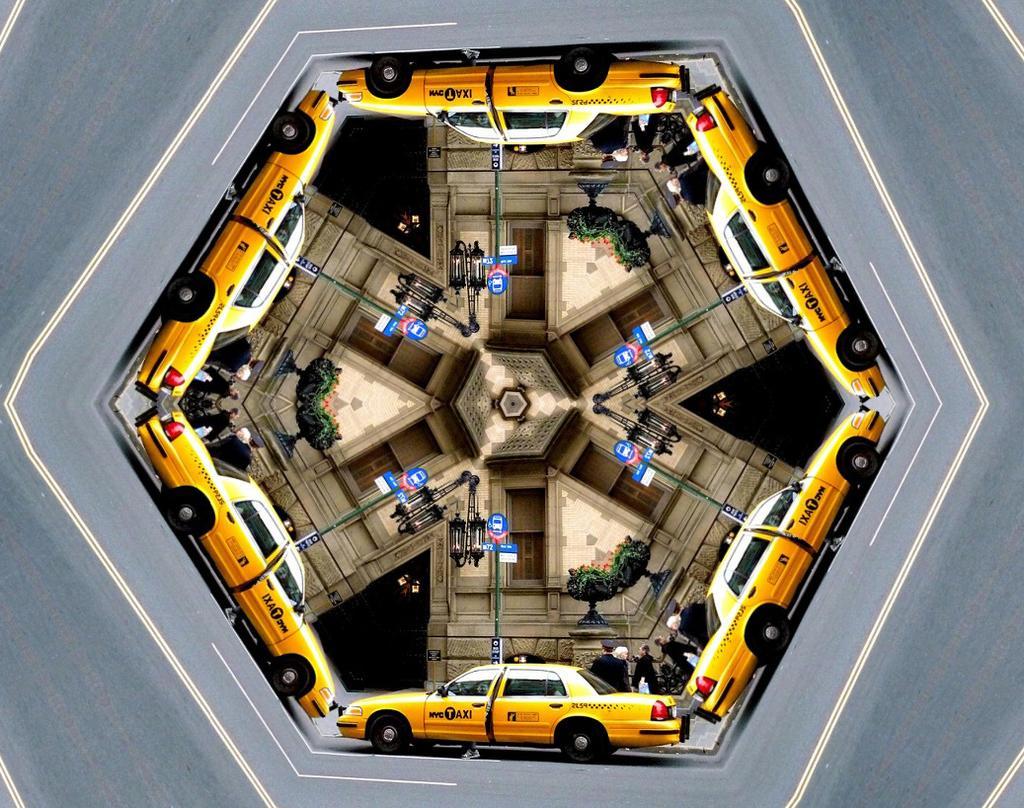Could you give a brief overview of what you see in this image? In the picture I can see the yellow color taxi car on the road, I can see caution boards, a person standing there, I can see the wall. This picture is in hexagon shape. 